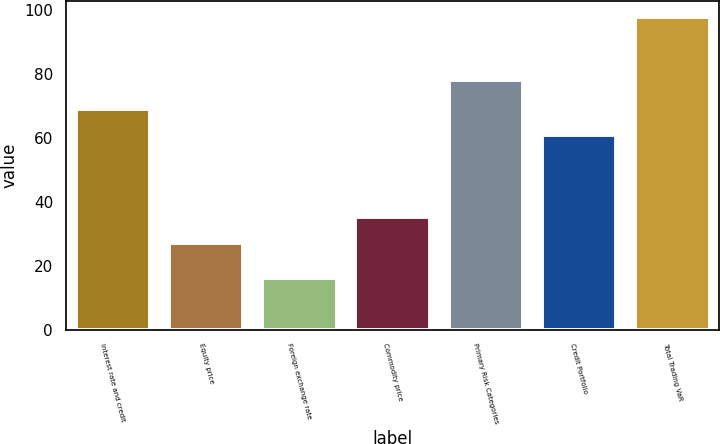Convert chart to OTSL. <chart><loc_0><loc_0><loc_500><loc_500><bar_chart><fcel>Interest rate and credit<fcel>Equity price<fcel>Foreign exchange rate<fcel>Commodity price<fcel>Primary Risk Categories<fcel>Credit Portfolio<fcel>Total Trading VaR<nl><fcel>69.2<fcel>27<fcel>16<fcel>35.2<fcel>78<fcel>61<fcel>98<nl></chart> 